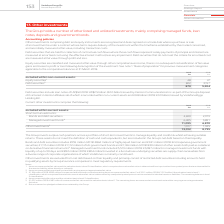From Vodafone Group Plc's financial document, What type of non-current investments are shown in the table? The document shows two values: Equity securities and Debt securities. From the document: "Equity securities are classified and measured at fair value through other comprehensive income, there is no subsequen Debt securities that are held fo..." Also, How much is the 2019 equity securities ? According to the financial document, 48 (in millions). The relevant text states: "ed within non-current assets: Equity securities 1 48 47 Debt securities 2 822 3,157 870 3,204..." Also, How much is the 2018 debt securities? According to the financial document, 3,157 (in millions). The relevant text states: ": Equity securities 1 48 47 Debt securities 2 822 3,157 870 3,204..." Also, can you calculate: What is the average equity securities? To answer this question, I need to perform calculations using the financial data. The calculation is: (48+47)/2, which equals 47.5 (in millions). This is based on the information: "within non-current assets: Equity securities 1 48 47 Debt securities 2 822 3,157 870 3,204 ed within non-current assets: Equity securities 1 48 47 Debt securities 2 822 3,157 870 3,204..." The key data points involved are: 48. Also, can you calculate: What is the average debt securities? To answer this question, I need to perform calculations using the financial data. The calculation is: (822+3,157)/2, which equals 1989.5 (in millions). This is based on the information: ": Equity securities 1 48 47 Debt securities 2 822 3,157 870 3,204 sets: Equity securities 1 48 47 Debt securities 2 822 3,157 870 3,204..." The key data points involved are: 3,157, 822. Also, can you calculate: What is the difference between average equity securities and average debt securities ? To answer this question, I need to perform calculations using the financial data. The calculation is: [(822+3,157)/2] - [(48+47)/2], which equals 1942 (in millions). This is based on the information: ": Equity securities 1 48 47 Debt securities 2 822 3,157 870 3,204 sets: Equity securities 1 48 47 Debt securities 2 822 3,157 870 3,204 153 Vodafone Group Plc Annual Report 2019 ed within non-current ..." The key data points involved are: 3,157, 47, 48. 